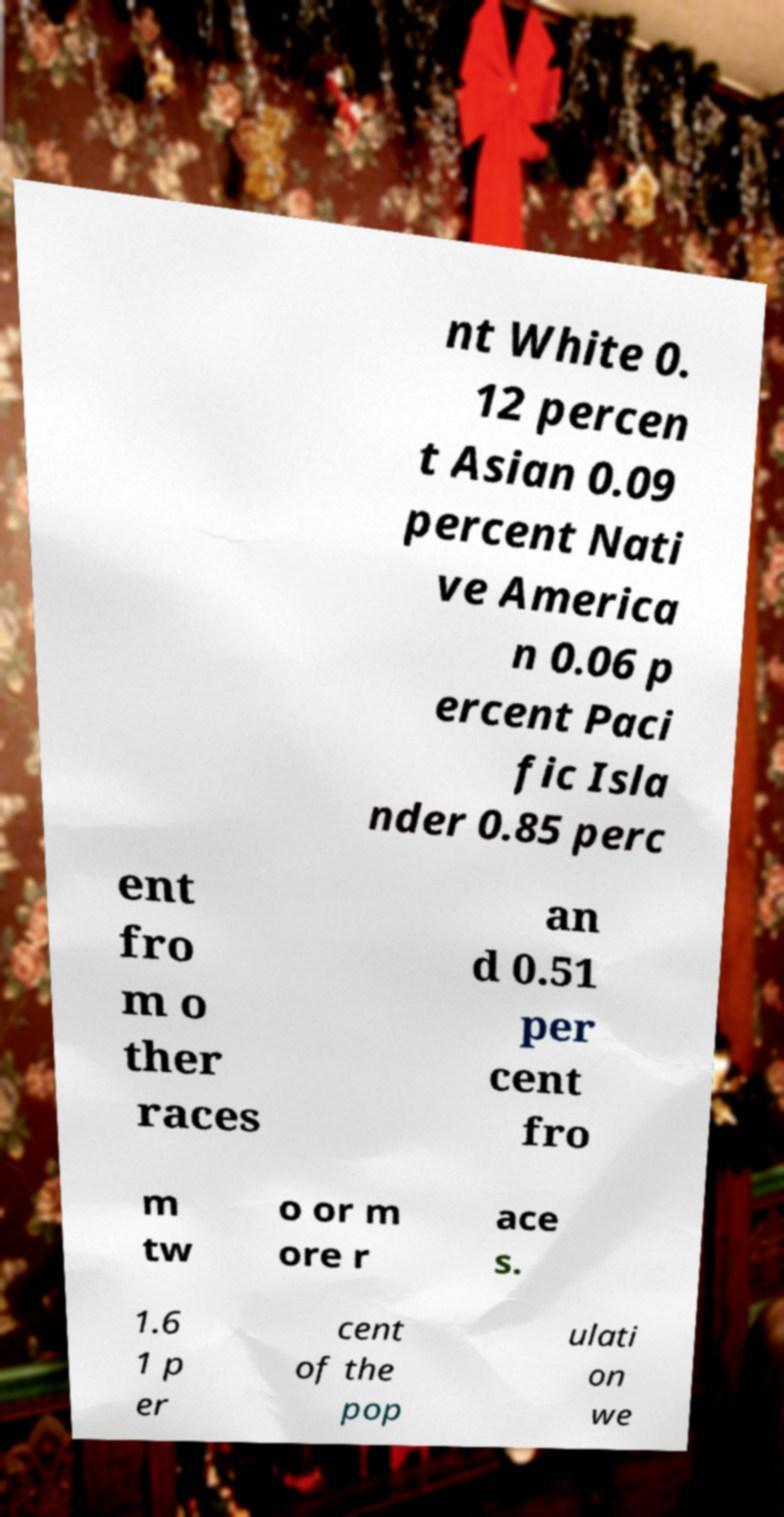Could you extract and type out the text from this image? nt White 0. 12 percen t Asian 0.09 percent Nati ve America n 0.06 p ercent Paci fic Isla nder 0.85 perc ent fro m o ther races an d 0.51 per cent fro m tw o or m ore r ace s. 1.6 1 p er cent of the pop ulati on we 